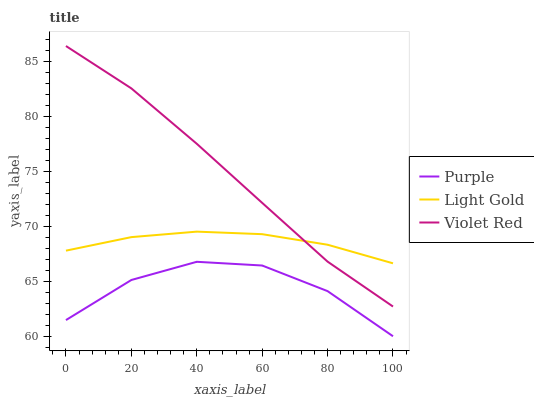Does Purple have the minimum area under the curve?
Answer yes or no. Yes. Does Violet Red have the maximum area under the curve?
Answer yes or no. Yes. Does Light Gold have the minimum area under the curve?
Answer yes or no. No. Does Light Gold have the maximum area under the curve?
Answer yes or no. No. Is Violet Red the smoothest?
Answer yes or no. Yes. Is Purple the roughest?
Answer yes or no. Yes. Is Light Gold the smoothest?
Answer yes or no. No. Is Light Gold the roughest?
Answer yes or no. No. Does Purple have the lowest value?
Answer yes or no. Yes. Does Violet Red have the lowest value?
Answer yes or no. No. Does Violet Red have the highest value?
Answer yes or no. Yes. Does Light Gold have the highest value?
Answer yes or no. No. Is Purple less than Light Gold?
Answer yes or no. Yes. Is Light Gold greater than Purple?
Answer yes or no. Yes. Does Light Gold intersect Violet Red?
Answer yes or no. Yes. Is Light Gold less than Violet Red?
Answer yes or no. No. Is Light Gold greater than Violet Red?
Answer yes or no. No. Does Purple intersect Light Gold?
Answer yes or no. No. 